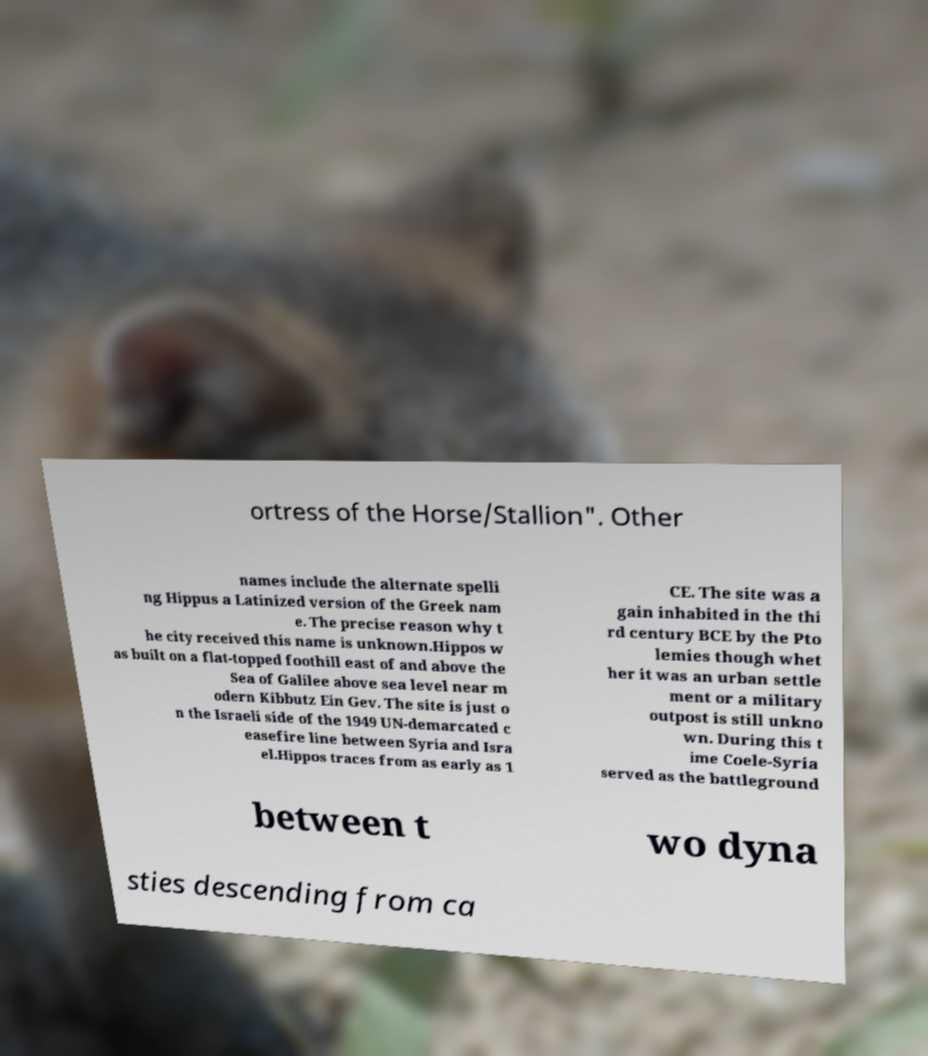For documentation purposes, I need the text within this image transcribed. Could you provide that? ortress of the Horse/Stallion". Other names include the alternate spelli ng Hippus a Latinized version of the Greek nam e. The precise reason why t he city received this name is unknown.Hippos w as built on a flat-topped foothill east of and above the Sea of Galilee above sea level near m odern Kibbutz Ein Gev. The site is just o n the Israeli side of the 1949 UN-demarcated c easefire line between Syria and Isra el.Hippos traces from as early as 1 CE. The site was a gain inhabited in the thi rd century BCE by the Pto lemies though whet her it was an urban settle ment or a military outpost is still unkno wn. During this t ime Coele-Syria served as the battleground between t wo dyna sties descending from ca 